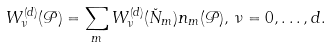Convert formula to latex. <formula><loc_0><loc_0><loc_500><loc_500>W _ { \nu } ^ { ( d ) } ( \mathcal { P } ) = \sum _ { m } W _ { \nu } ^ { ( d ) } ( \breve { N } _ { m } ) n _ { m } ( \mathcal { P } ) , \, \nu = 0 , \dots , d .</formula> 